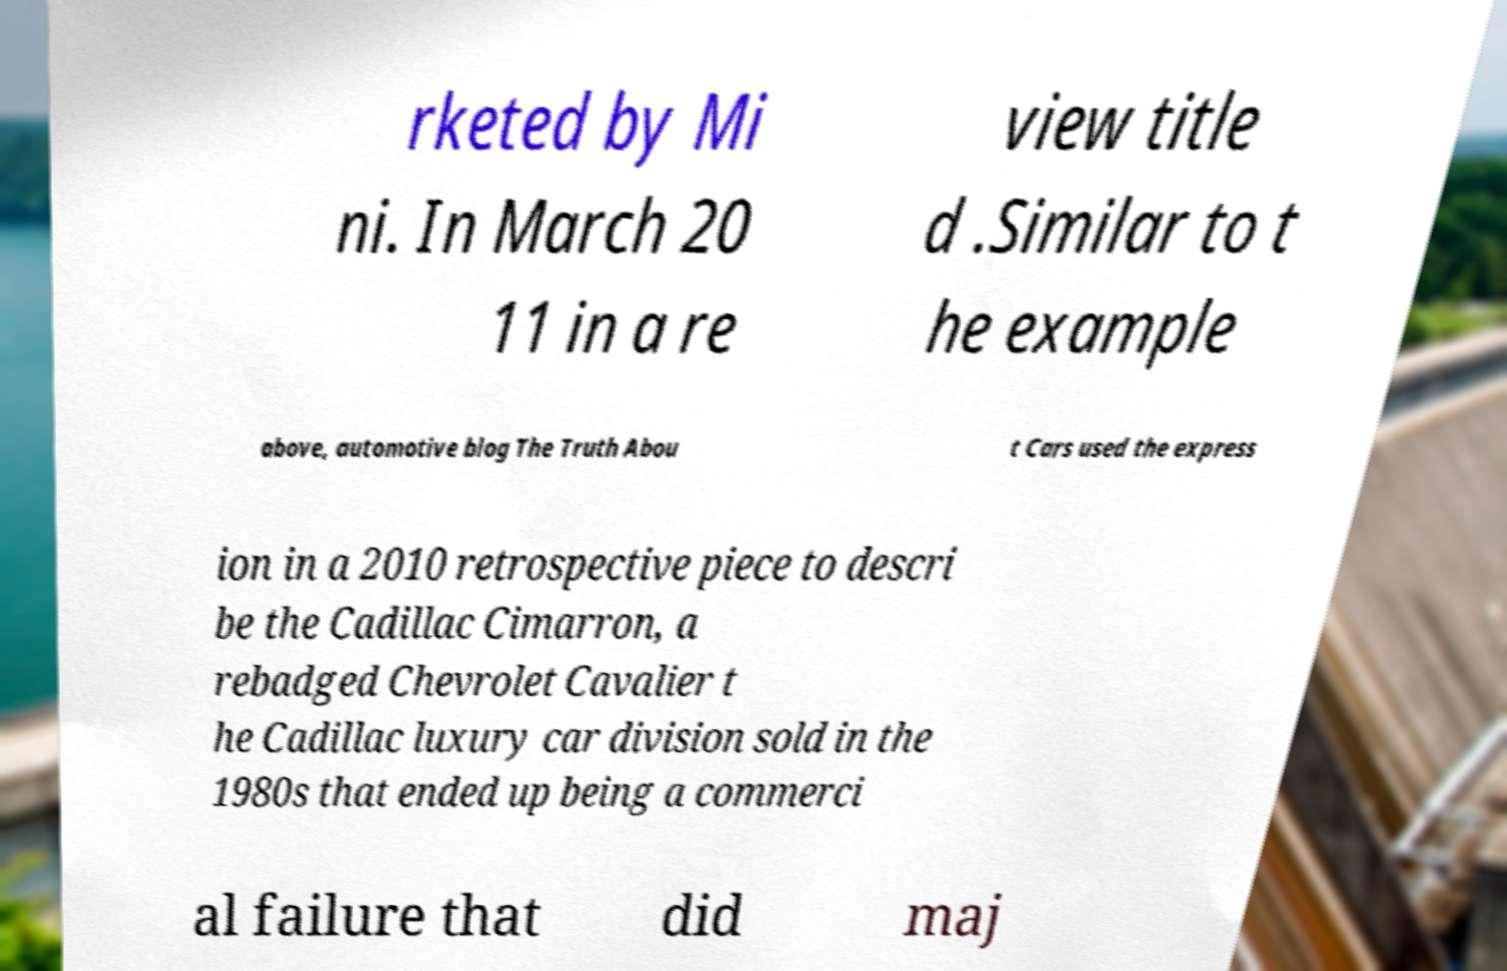There's text embedded in this image that I need extracted. Can you transcribe it verbatim? rketed by Mi ni. In March 20 11 in a re view title d .Similar to t he example above, automotive blog The Truth Abou t Cars used the express ion in a 2010 retrospective piece to descri be the Cadillac Cimarron, a rebadged Chevrolet Cavalier t he Cadillac luxury car division sold in the 1980s that ended up being a commerci al failure that did maj 